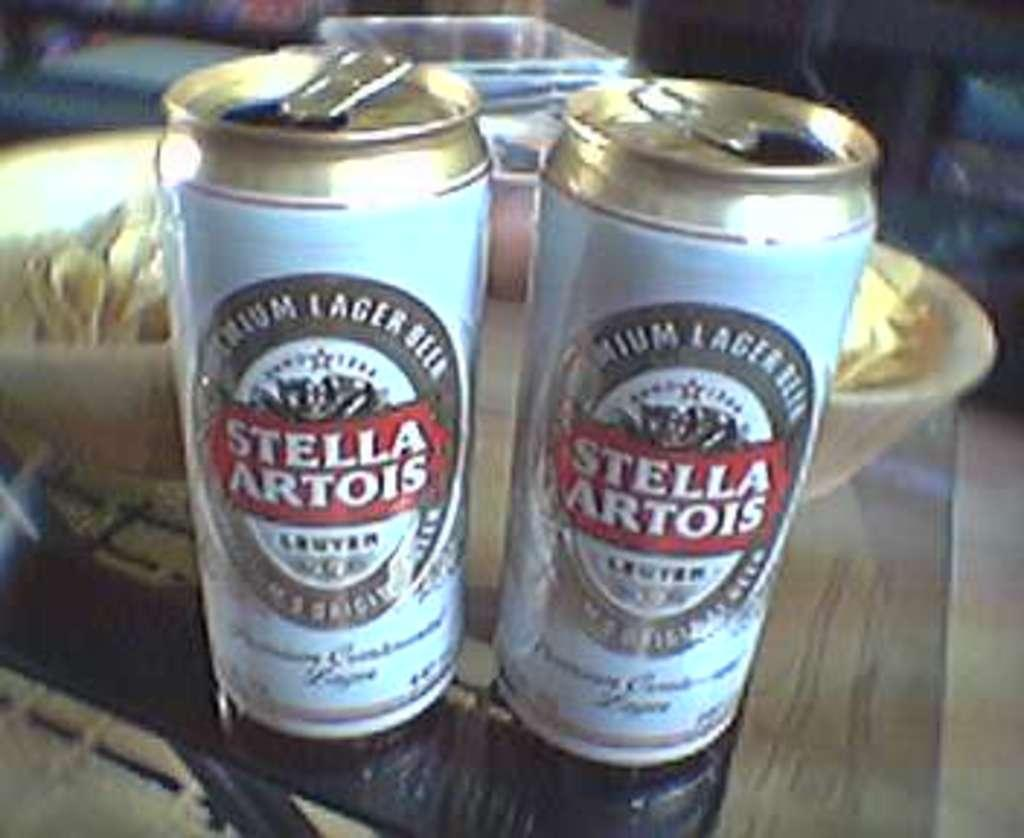Provide a one-sentence caption for the provided image. Two cans of Stella Artois sit side by side. 